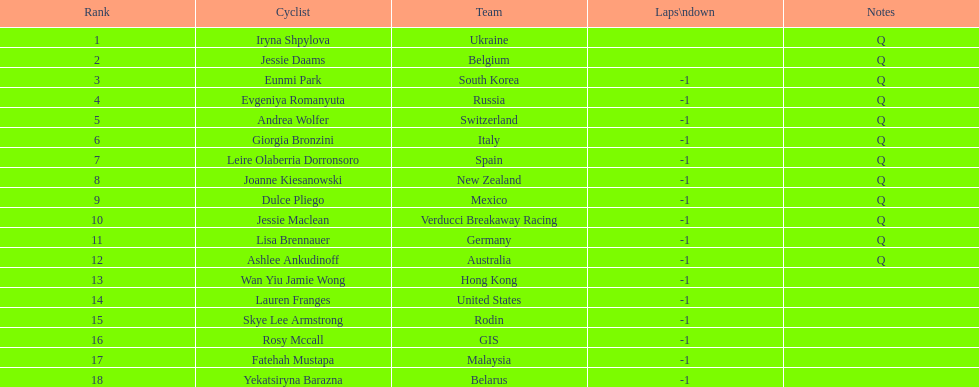Who was the highest ranked participant in this race? Iryna Shpylova. 